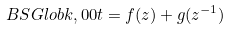<formula> <loc_0><loc_0><loc_500><loc_500>\ B S G l o b { k , 0 } { 0 } { t } = f ( z ) + g ( z ^ { - 1 } )</formula> 